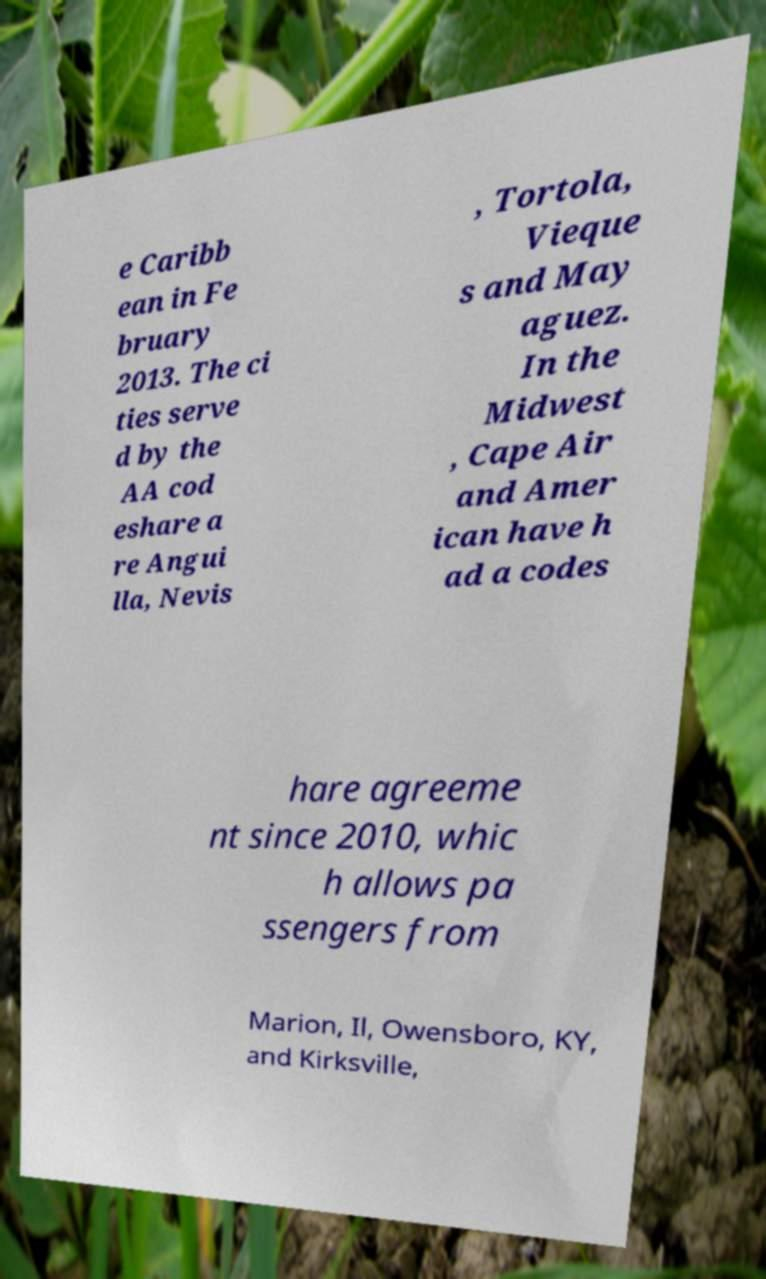Could you assist in decoding the text presented in this image and type it out clearly? e Caribb ean in Fe bruary 2013. The ci ties serve d by the AA cod eshare a re Angui lla, Nevis , Tortola, Vieque s and May aguez. In the Midwest , Cape Air and Amer ican have h ad a codes hare agreeme nt since 2010, whic h allows pa ssengers from Marion, Il, Owensboro, KY, and Kirksville, 